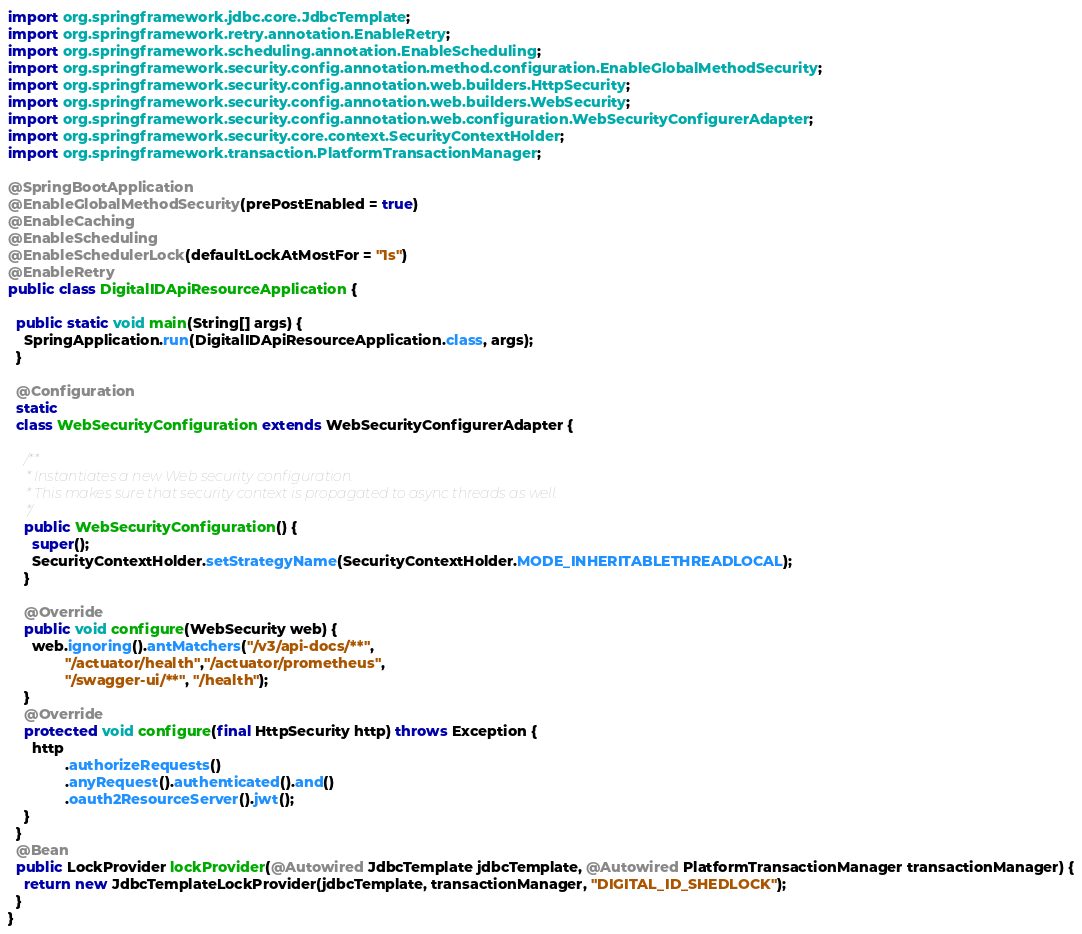<code> <loc_0><loc_0><loc_500><loc_500><_Java_>import org.springframework.jdbc.core.JdbcTemplate;
import org.springframework.retry.annotation.EnableRetry;
import org.springframework.scheduling.annotation.EnableScheduling;
import org.springframework.security.config.annotation.method.configuration.EnableGlobalMethodSecurity;
import org.springframework.security.config.annotation.web.builders.HttpSecurity;
import org.springframework.security.config.annotation.web.builders.WebSecurity;
import org.springframework.security.config.annotation.web.configuration.WebSecurityConfigurerAdapter;
import org.springframework.security.core.context.SecurityContextHolder;
import org.springframework.transaction.PlatformTransactionManager;

@SpringBootApplication
@EnableGlobalMethodSecurity(prePostEnabled = true)
@EnableCaching
@EnableScheduling
@EnableSchedulerLock(defaultLockAtMostFor = "1s")
@EnableRetry
public class DigitalIDApiResourceApplication {

  public static void main(String[] args) {
    SpringApplication.run(DigitalIDApiResourceApplication.class, args);
  }

  @Configuration
  static
  class WebSecurityConfiguration extends WebSecurityConfigurerAdapter {

    /**
     * Instantiates a new Web security configuration.
     * This makes sure that security context is propagated to async threads as well.
     */
    public WebSecurityConfiguration() {
      super();
      SecurityContextHolder.setStrategyName(SecurityContextHolder.MODE_INHERITABLETHREADLOCAL);
    }

    @Override
    public void configure(WebSecurity web) {
      web.ignoring().antMatchers("/v3/api-docs/**",
              "/actuator/health","/actuator/prometheus",
              "/swagger-ui/**", "/health");
    }
    @Override
    protected void configure(final HttpSecurity http) throws Exception {
      http
              .authorizeRequests()
              .anyRequest().authenticated().and()
              .oauth2ResourceServer().jwt();
    }
  }
  @Bean
  public LockProvider lockProvider(@Autowired JdbcTemplate jdbcTemplate, @Autowired PlatformTransactionManager transactionManager) {
    return new JdbcTemplateLockProvider(jdbcTemplate, transactionManager, "DIGITAL_ID_SHEDLOCK");
  }
}

</code> 